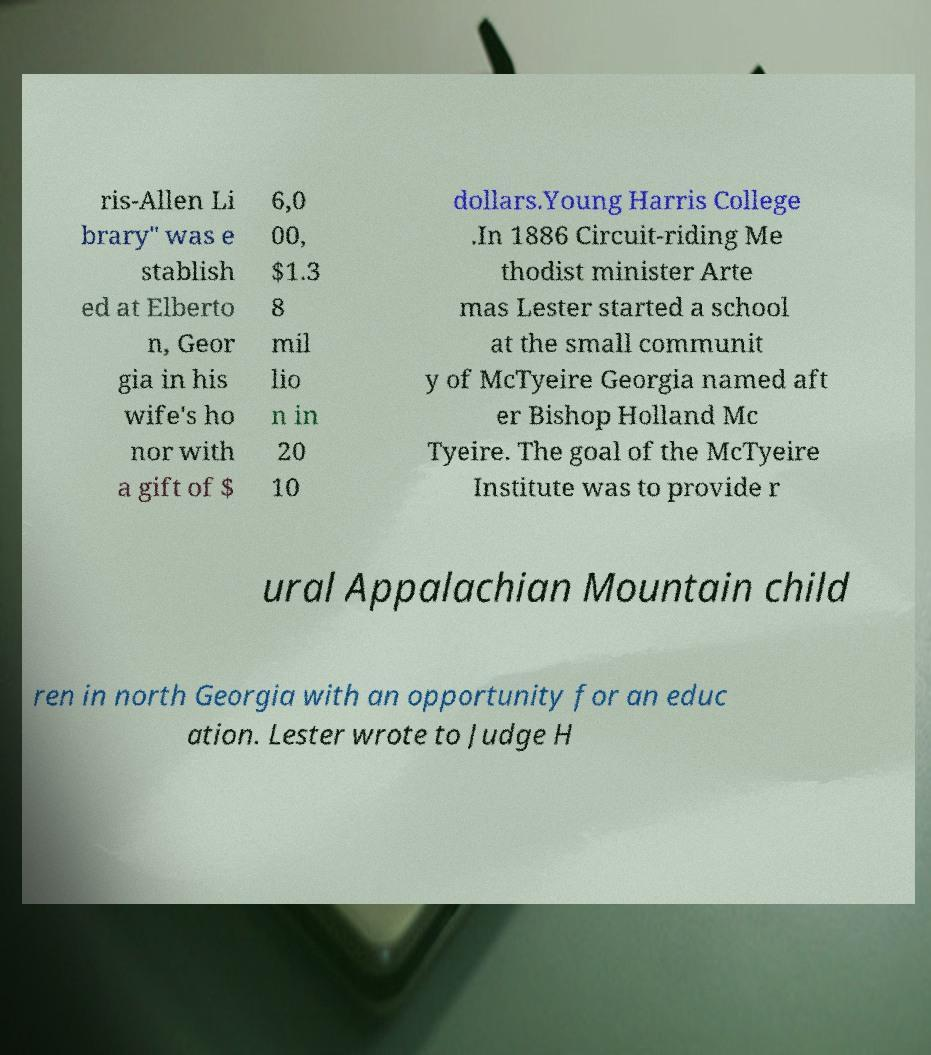I need the written content from this picture converted into text. Can you do that? ris-Allen Li brary" was e stablish ed at Elberto n, Geor gia in his wife's ho nor with a gift of $ 6,0 00, $1.3 8 mil lio n in 20 10 dollars.Young Harris College .In 1886 Circuit-riding Me thodist minister Arte mas Lester started a school at the small communit y of McTyeire Georgia named aft er Bishop Holland Mc Tyeire. The goal of the McTyeire Institute was to provide r ural Appalachian Mountain child ren in north Georgia with an opportunity for an educ ation. Lester wrote to Judge H 